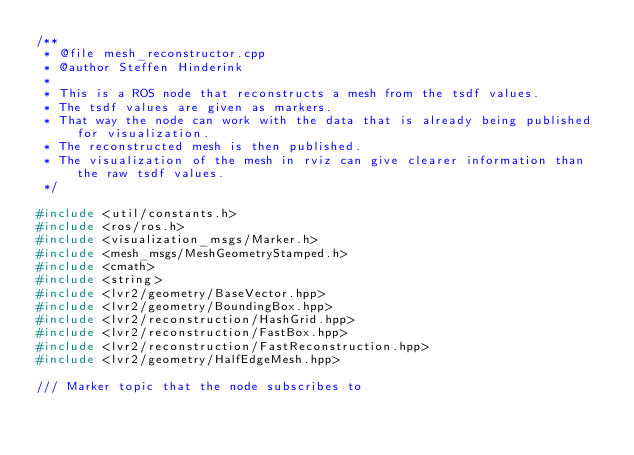Convert code to text. <code><loc_0><loc_0><loc_500><loc_500><_C++_>/**
 * @file mesh_reconstructor.cpp
 * @author Steffen Hinderink
 * 
 * This is a ROS node that reconstructs a mesh from the tsdf values.
 * The tsdf values are given as markers.
 * That way the node can work with the data that is already being published for visualization.
 * The reconstructed mesh is then published.
 * The visualization of the mesh in rviz can give clearer information than the raw tsdf values.
 */

#include <util/constants.h>
#include <ros/ros.h>
#include <visualization_msgs/Marker.h>
#include <mesh_msgs/MeshGeometryStamped.h>
#include <cmath>
#include <string>
#include <lvr2/geometry/BaseVector.hpp>
#include <lvr2/geometry/BoundingBox.hpp>
#include <lvr2/reconstruction/HashGrid.hpp>
#include <lvr2/reconstruction/FastBox.hpp>
#include <lvr2/reconstruction/FastReconstruction.hpp>
#include <lvr2/geometry/HalfEdgeMesh.hpp>

/// Marker topic that the node subscribes to</code> 